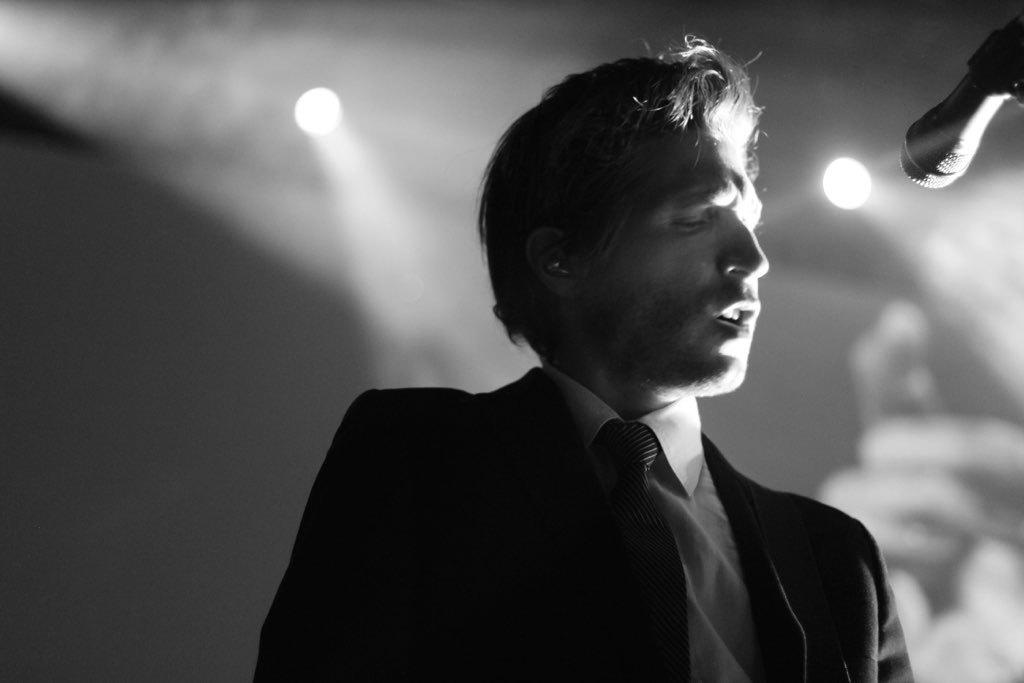Who is present in the image? There is a man in the image. What is the man doing in the image? The man is standing near a microphone. What is the man wearing in the image? The man is wearing a blazer, a tie, and a white shirt. What can be seen on the wall in the image? There are focus lights on the wall in the image. How does the man interact with the crowd in the image? There is no crowd present in the image; it only features the man standing near a microphone. What type of flight is the man preparing for in the image? There is no reference to a flight or any aviation-related activity in the image. 